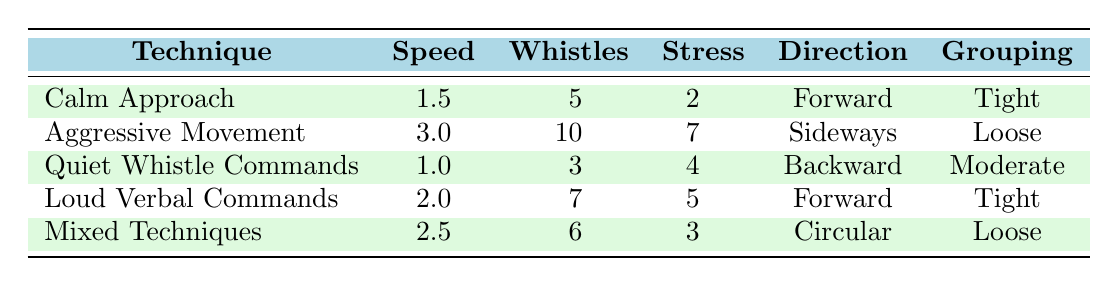What is the whistle command count for the "Aggressive Movement" technique? The table lists the "Aggressive Movement" technique in a row, and in the corresponding column for "Whistles," it shows a count of 10.
Answer: 10 What is the speed of movement for "Quiet Whistle Commands"? Looking at the row for "Quiet Whistle Commands," the "Speed" column shows a value of 1.0.
Answer: 1.0 Which technique has the highest stress level? Reviewing the "Stress" column, "Aggressive Movement" has the highest value of 7 compared to the others.
Answer: Aggressive Movement Is the livestock grouping "Tight" associated with a higher or lower average speed of movement compared to "Loose"? The average speed of "Tight" is (1.5 + 2.0) / 2 = 1.75, while for "Loose" it is (3.0 + 2.5) / 2 = 2.75. The "Loose" grouping has a higher average speed than "Tight."
Answer: Higher What is the average whistle command count for all techniques? Summing the whistle command counts: 5 + 10 + 3 + 7 + 6 = 31. There are 5 techniques, so the average is 31 / 5 = 6.2.
Answer: 6.2 Does "Calm Approach" or "Mixed Techniques" have a higher stress level? The stress level for "Calm Approach" is 2, while for "Mixed Techniques" it is 3. Comparing these, "Mixed Techniques" has a higher stress level.
Answer: Mixed Techniques Which technique has the fastest speed of movement, and what is that speed? Reviewing the table, "Aggressive Movement" has the highest speed of 3.0 compared to the other techniques listed.
Answer: Aggressive Movement, 3.0 Calculate the difference in whistle commands between "Loud Verbal Commands" and "Quiet Whistle Commands." The whistle commands for "Loud Verbal Commands" is 7 and for "Quiet Whistle Commands" it is 3. The difference is 7 - 3 = 4.
Answer: 4 Does increasing speed of movement correlate with a higher stress level based on the data? By observing the data, "Aggressive Movement" has the highest speed (3.0) and the highest stress (7), while the lowest speed (1.0) has a lower stress (4). However, "Calm Approach" with a similar low speed has lower stress (2). Thus, there is not a clear correlation.
Answer: No 